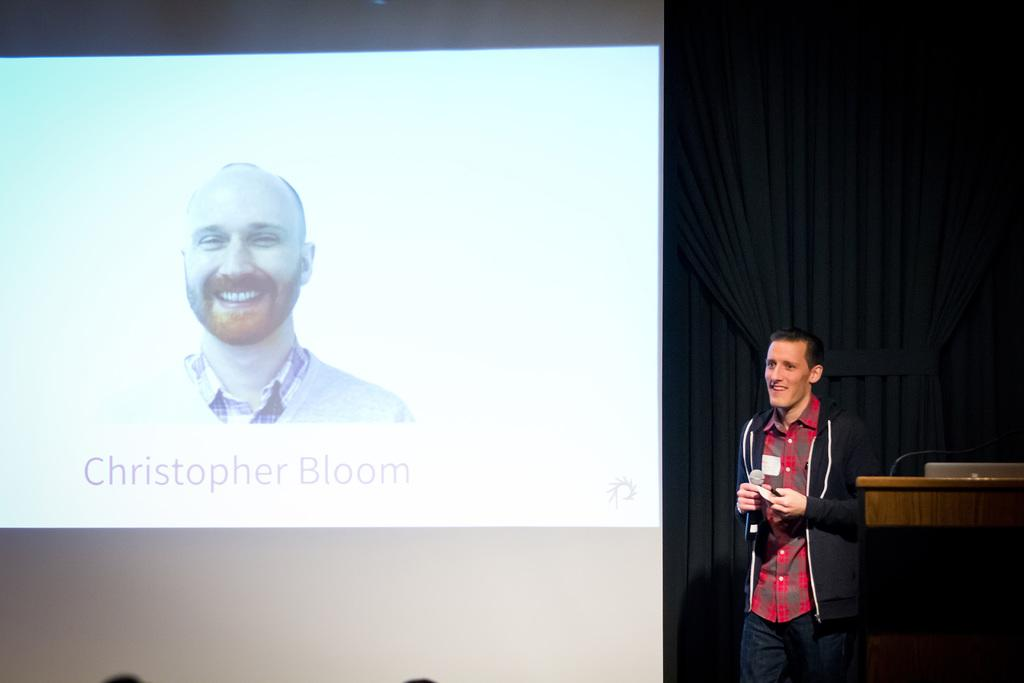Who or what is in the image? There is a person in the image. What is the person holding? The person is holding a mic. What can be seen near the person? There is a stand near the person. What is visible in the background? There is a screen and curtains in the background. What is displayed on the screen? A person and a text are visible on the screen. What is the weight of the flag in the image? There is no flag present in the image, so its weight cannot be determined. 